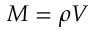Convert formula to latex. <formula><loc_0><loc_0><loc_500><loc_500>M = \rho V</formula> 